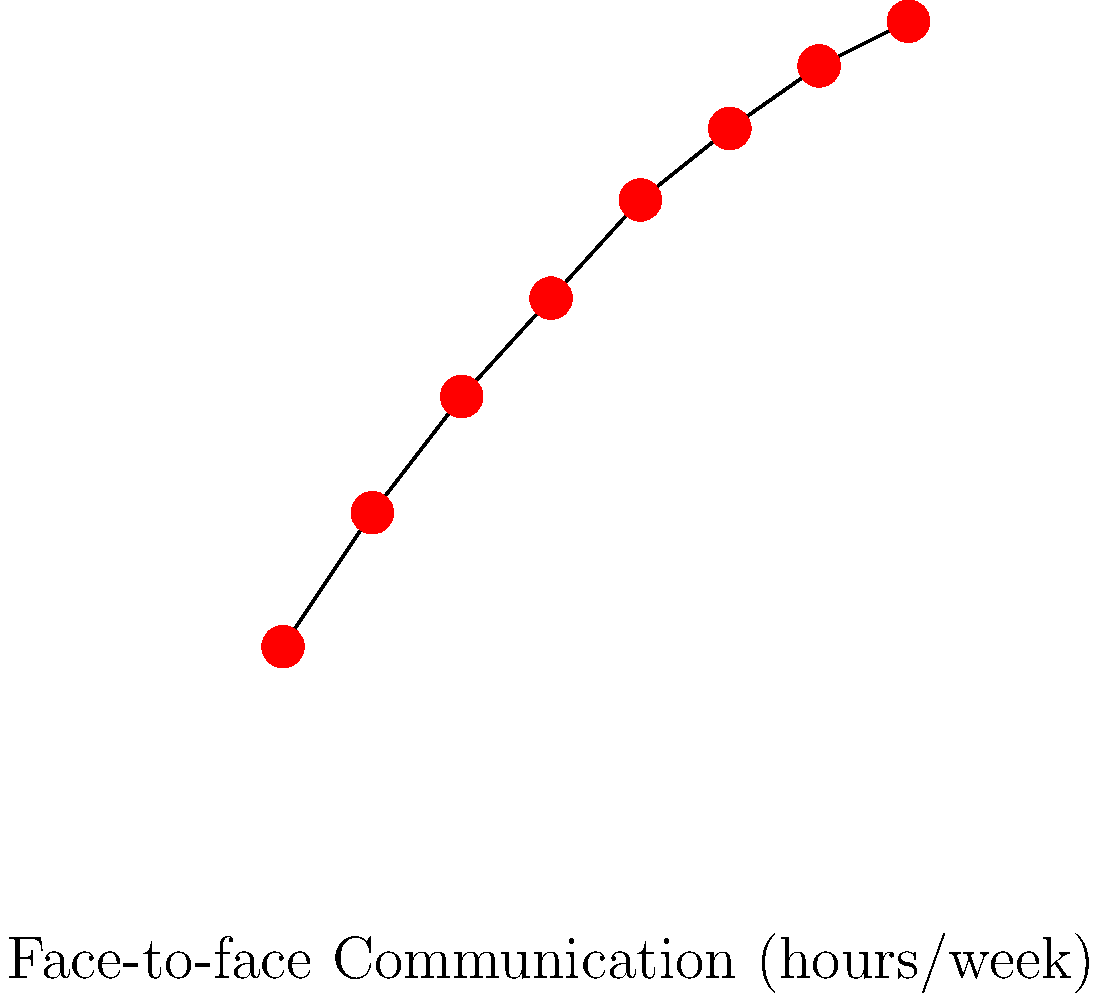Based on the scatter plot showing the relationship between face-to-face communication and empathy scores, what can be inferred about the correlation between these two variables? How might this information be relevant to promoting smartphone-free family time? To answer this question, let's analyze the scatter plot step-by-step:

1. Observe the overall trend: The data points show a clear upward trend from left to right.

2. Assess the correlation: The points form a relatively tight, linear pattern, indicating a strong positive correlation between face-to-face communication and empathy scores.

3. Interpret the correlation: As the amount of face-to-face communication increases, empathy scores tend to increase as well.

4. Quantify the relationship: For every increase of about 1 hour per week in face-to-face communication, there's approximately a 1-point increase in the empathy score.

5. Consider the implications: This strong positive correlation suggests that more face-to-face communication is associated with higher empathy levels.

6. Relate to smartphone-free family time: By promoting smartphone-free family time, we can encourage more face-to-face communication, which, according to this data, may lead to increased empathy among family members.

7. Reflect on the persona: As a sibling promoting a smartphone-free environment during family time, this data supports the importance of such practices in fostering empathy and stronger family bonds.
Answer: Strong positive correlation; supports smartphone-free family time to enhance empathy. 